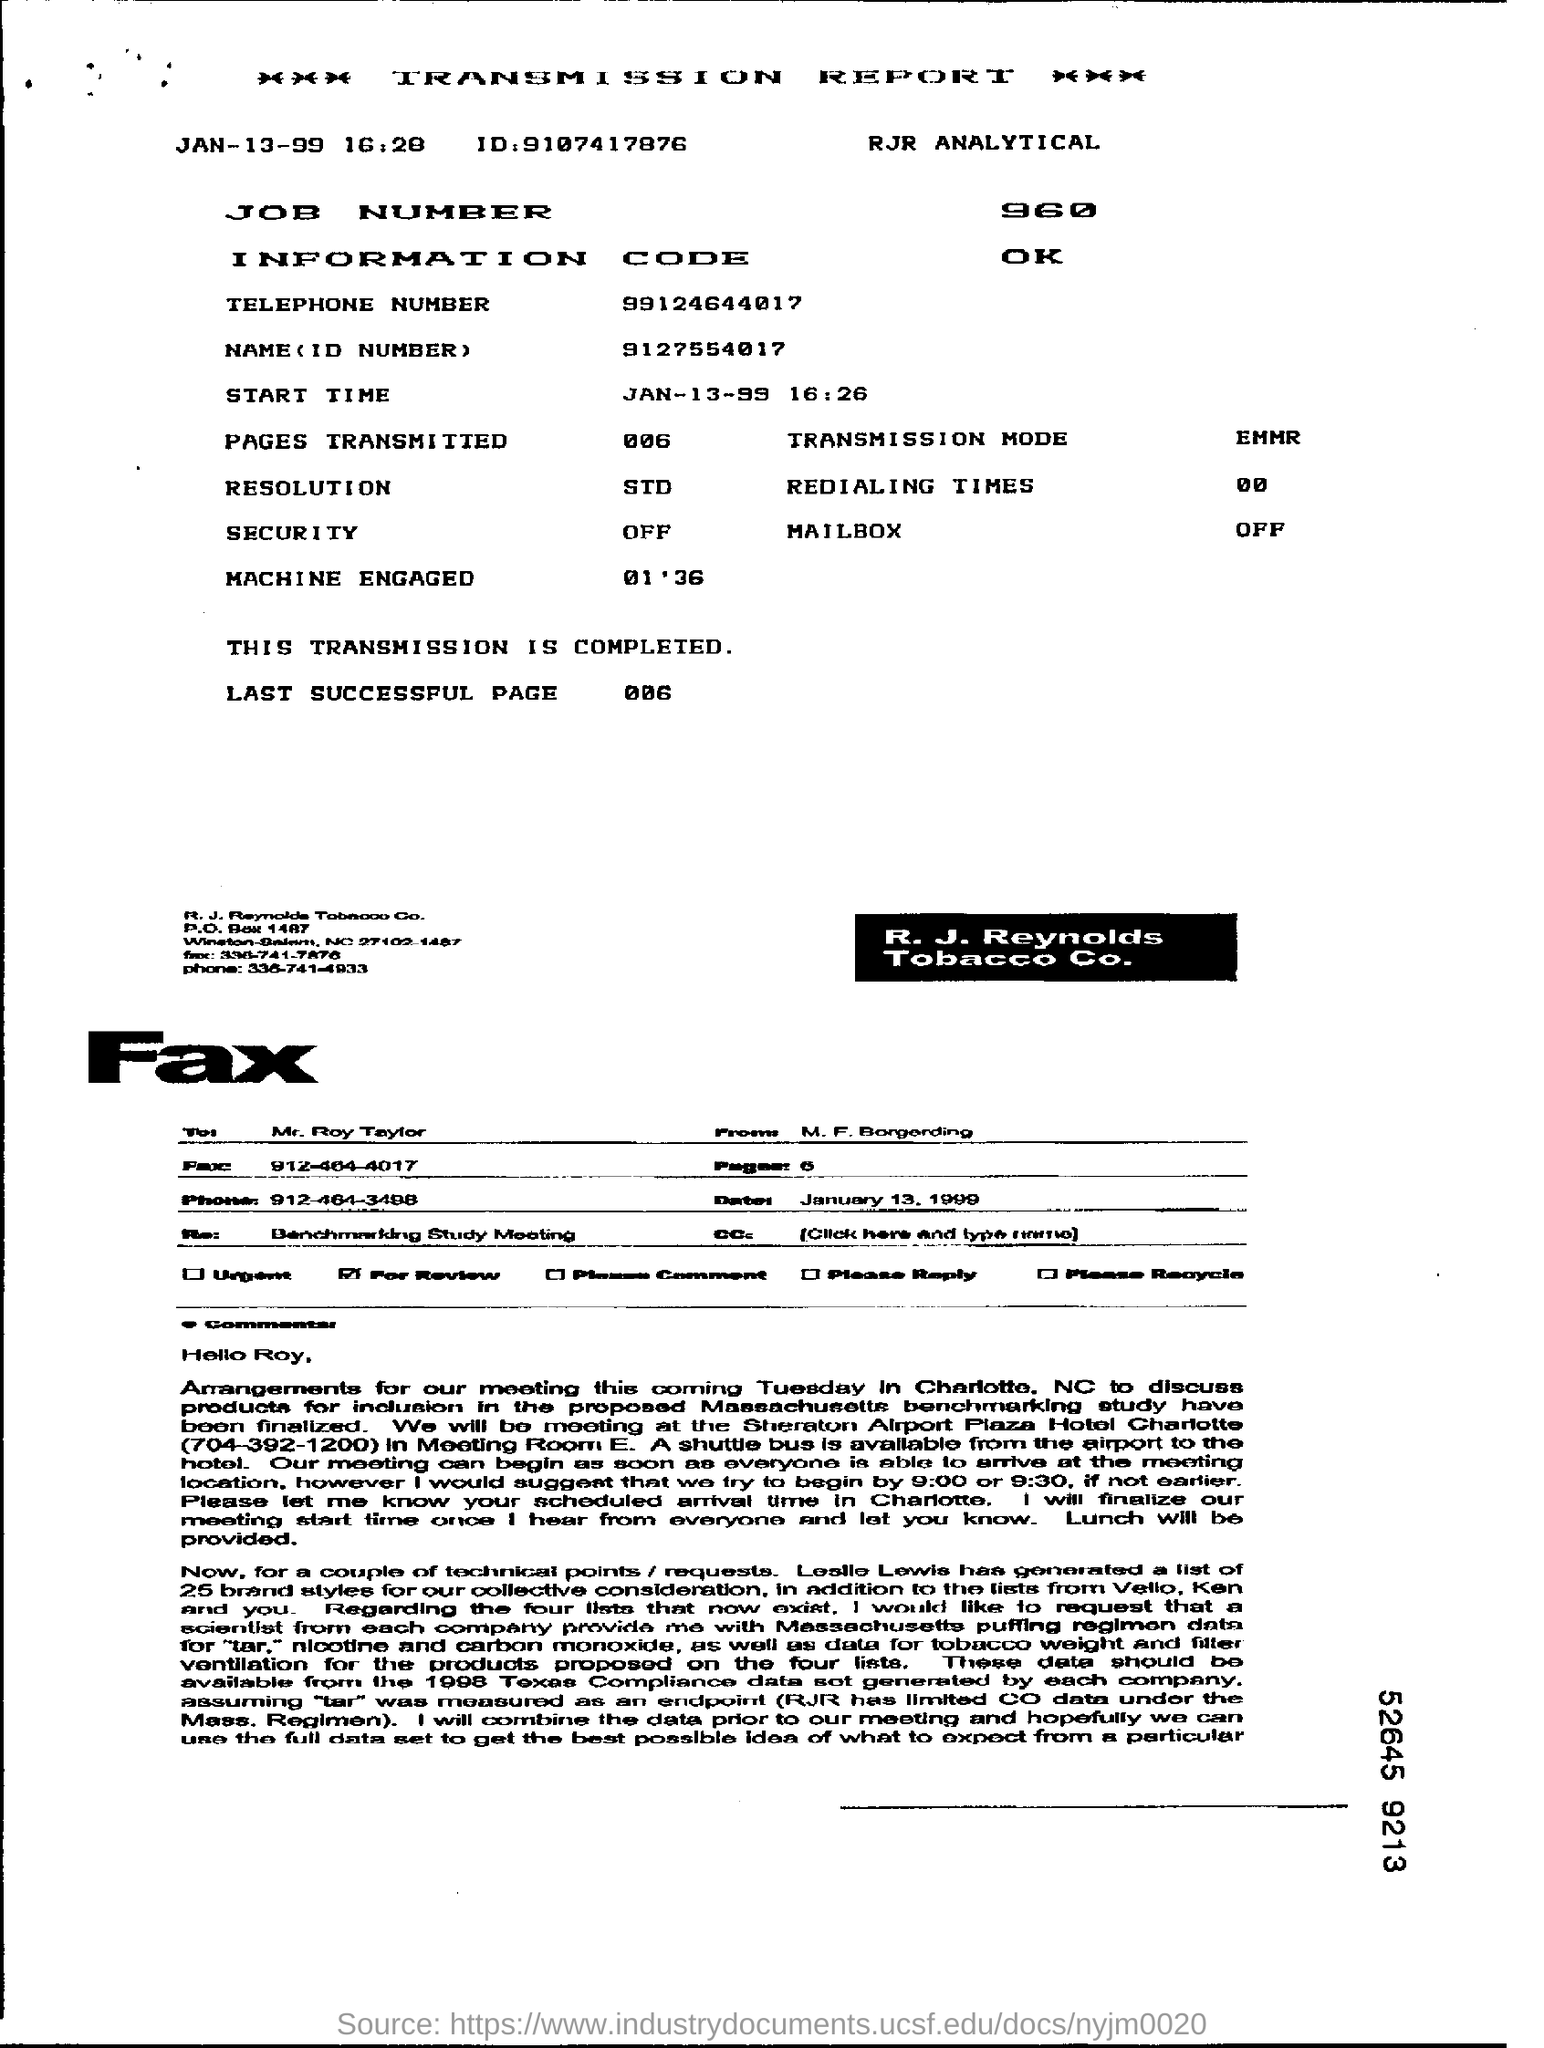Outline some significant characteristics in this image. The job number is 960.. The Information Code is a concept that encompasses the idea that information is fundamental to the universe and underlies all phenomena. The start time is January 13, 1999 at 4:26 PM. This transmission report is the one that is being referred to. 